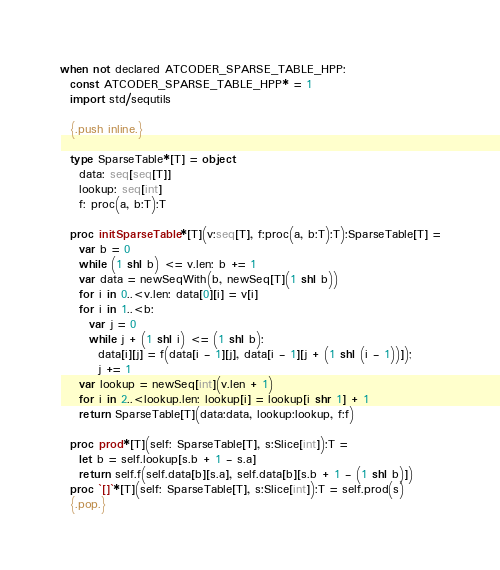Convert code to text. <code><loc_0><loc_0><loc_500><loc_500><_Nim_>when not declared ATCODER_SPARSE_TABLE_HPP:
  const ATCODER_SPARSE_TABLE_HPP* = 1
  import std/sequtils

  {.push inline.}

  type SparseTable*[T] = object
    data: seq[seq[T]]
    lookup: seq[int]
    f: proc(a, b:T):T

  proc initSparseTable*[T](v:seq[T], f:proc(a, b:T):T):SparseTable[T] =
    var b = 0
    while (1 shl b) <= v.len: b += 1
    var data = newSeqWith(b, newSeq[T](1 shl b))
    for i in 0..<v.len: data[0][i] = v[i]
    for i in 1..<b:
      var j = 0
      while j + (1 shl i) <= (1 shl b):
        data[i][j] = f(data[i - 1][j], data[i - 1][j + (1 shl (i - 1))]);
        j += 1
    var lookup = newSeq[int](v.len + 1)
    for i in 2..<lookup.len: lookup[i] = lookup[i shr 1] + 1
    return SparseTable[T](data:data, lookup:lookup, f:f)

  proc prod*[T](self: SparseTable[T], s:Slice[int]):T =
    let b = self.lookup[s.b + 1 - s.a]
    return self.f(self.data[b][s.a], self.data[b][s.b + 1 - (1 shl b)])
  proc `[]`*[T](self: SparseTable[T], s:Slice[int]):T = self.prod(s)
  {.pop.}
</code> 